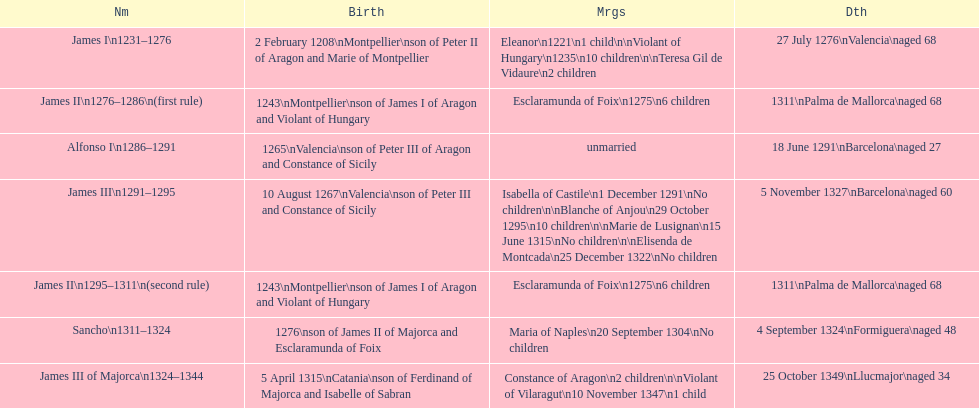How many of these rulers died prior to the age of 65? 4. 